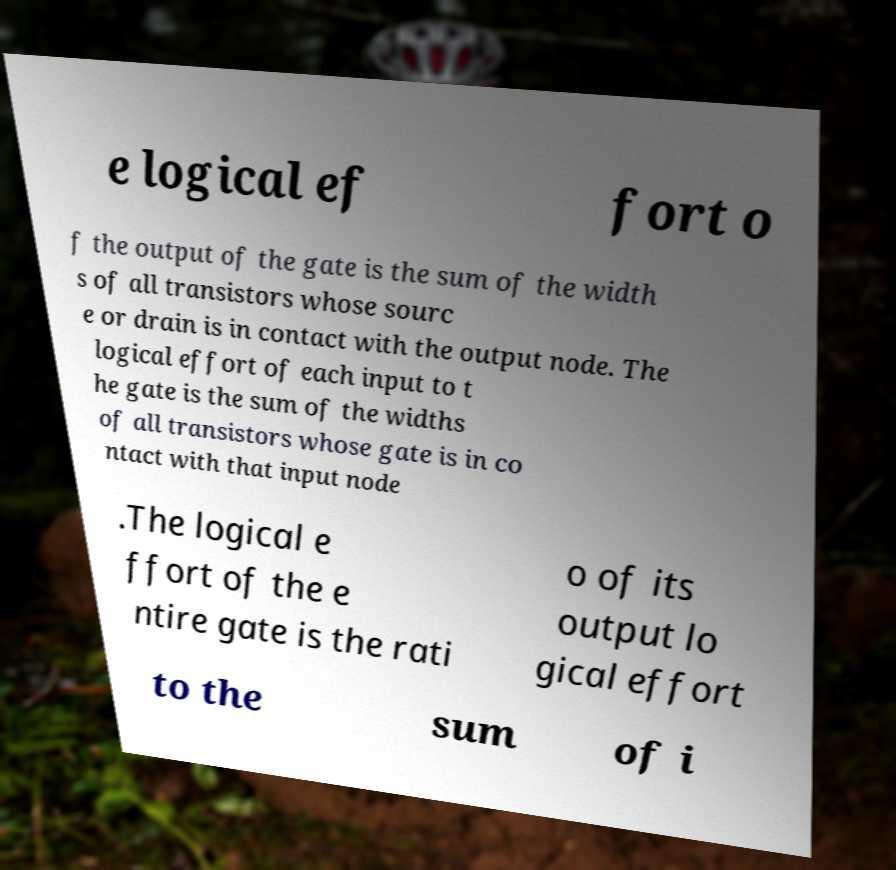Could you extract and type out the text from this image? e logical ef fort o f the output of the gate is the sum of the width s of all transistors whose sourc e or drain is in contact with the output node. The logical effort of each input to t he gate is the sum of the widths of all transistors whose gate is in co ntact with that input node .The logical e ffort of the e ntire gate is the rati o of its output lo gical effort to the sum of i 